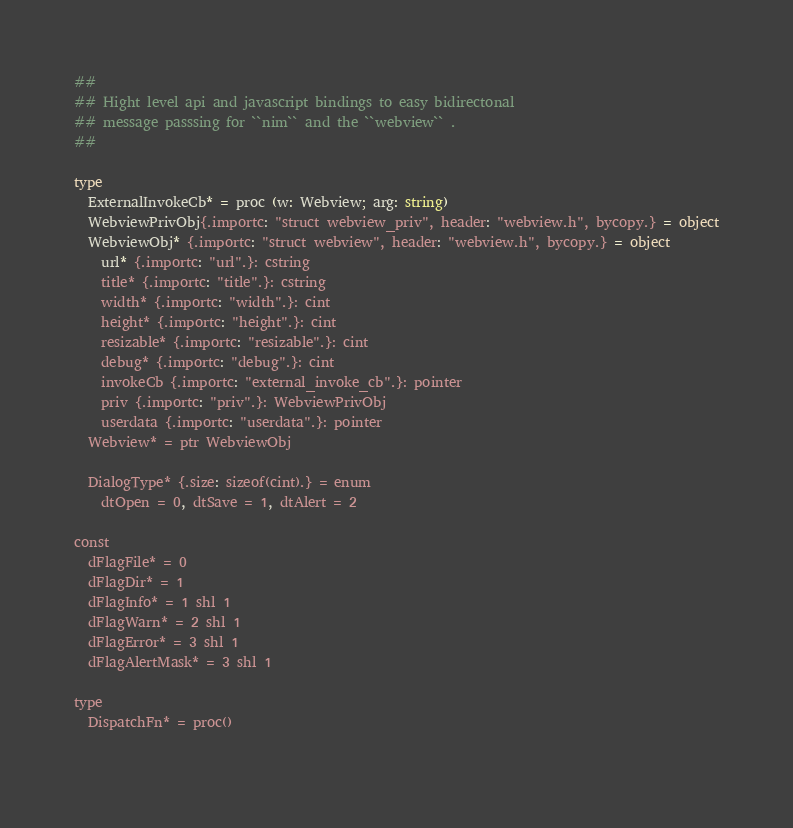Convert code to text. <code><loc_0><loc_0><loc_500><loc_500><_Nim_>
##
## Hight level api and javascript bindings to easy bidirectonal 
## message passsing for ``nim`` and the ``webview`` .
##

type
  ExternalInvokeCb* = proc (w: Webview; arg: string)
  WebviewPrivObj{.importc: "struct webview_priv", header: "webview.h", bycopy.} = object
  WebviewObj* {.importc: "struct webview", header: "webview.h", bycopy.} = object
    url* {.importc: "url".}: cstring
    title* {.importc: "title".}: cstring
    width* {.importc: "width".}: cint
    height* {.importc: "height".}: cint
    resizable* {.importc: "resizable".}: cint
    debug* {.importc: "debug".}: cint
    invokeCb {.importc: "external_invoke_cb".}: pointer
    priv {.importc: "priv".}: WebviewPrivObj
    userdata {.importc: "userdata".}: pointer
  Webview* = ptr WebviewObj

  DialogType* {.size: sizeof(cint).} = enum
    dtOpen = 0, dtSave = 1, dtAlert = 2
  
const
  dFlagFile* = 0
  dFlagDir* = 1
  dFlagInfo* = 1 shl 1
  dFlagWarn* = 2 shl 1
  dFlagError* = 3 shl 1
  dFlagAlertMask* = 3 shl 1
  
type
  DispatchFn* = proc()
  </code> 